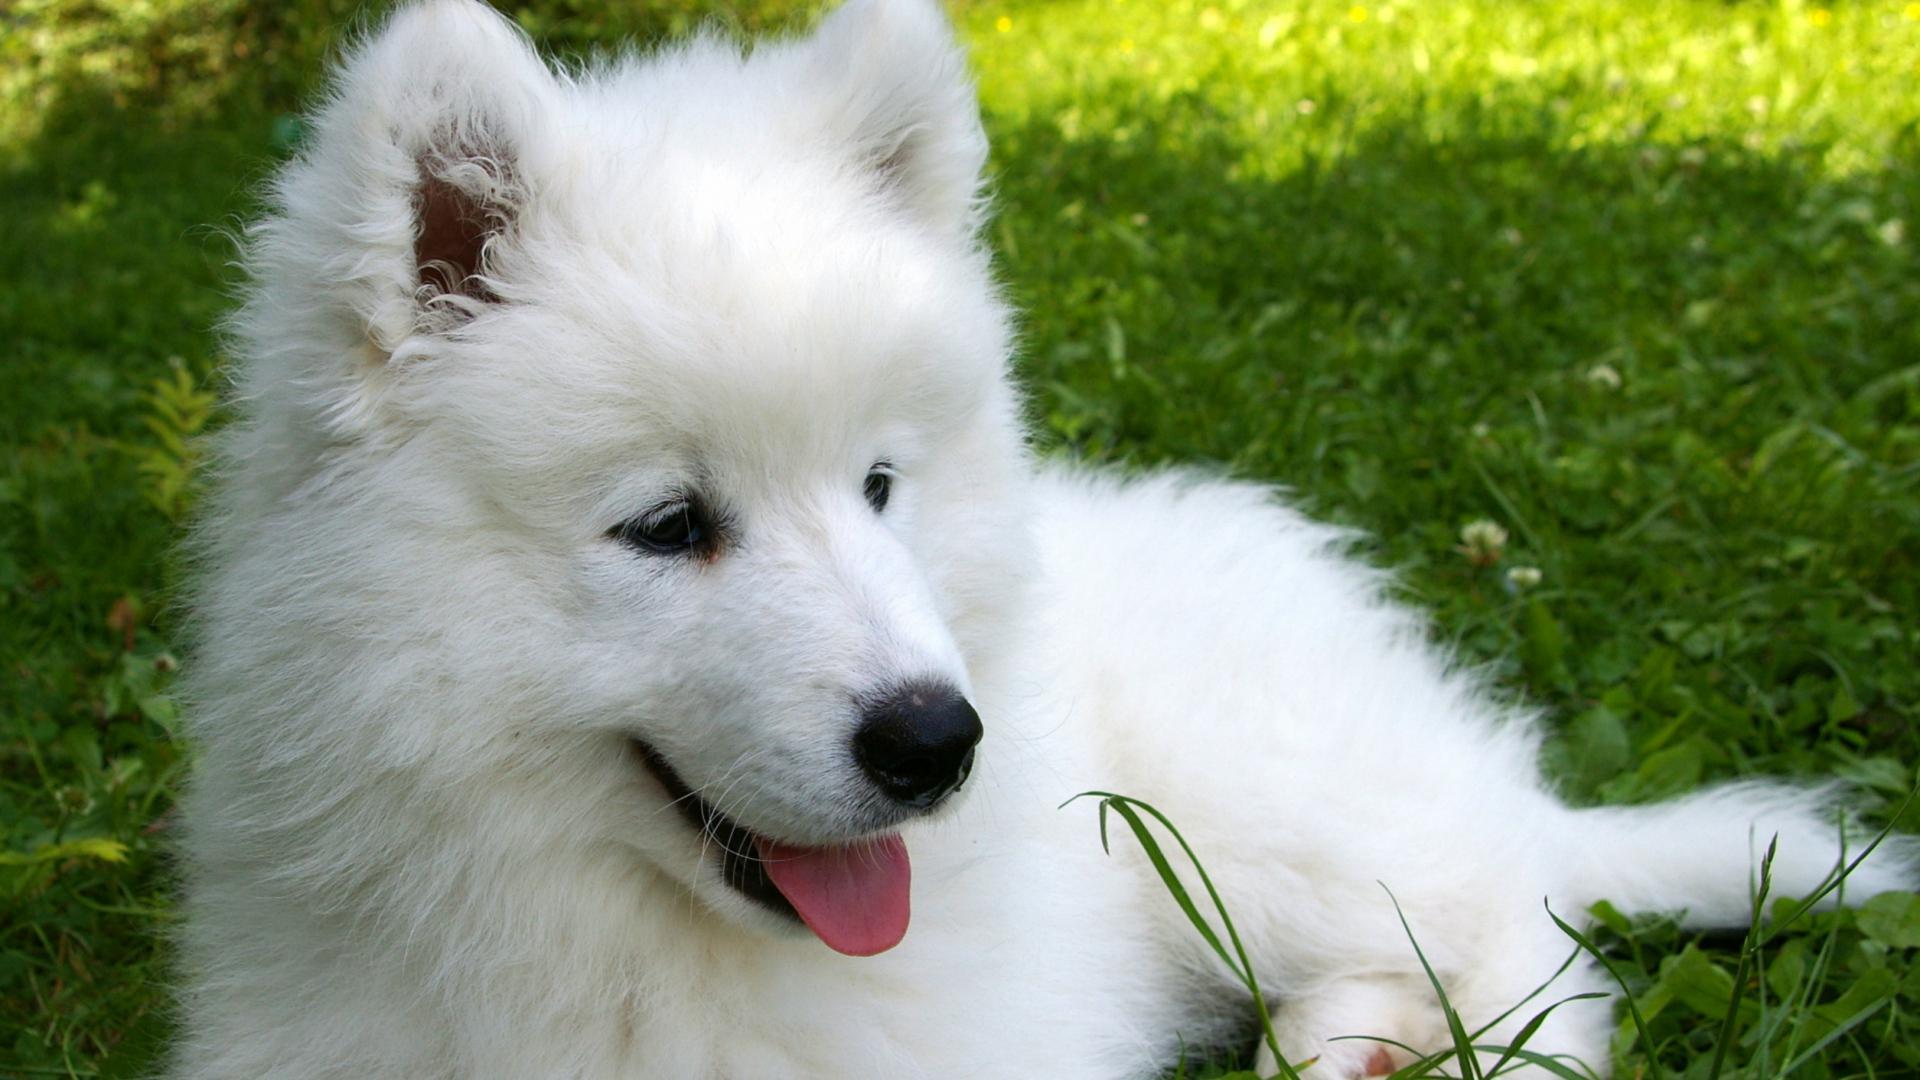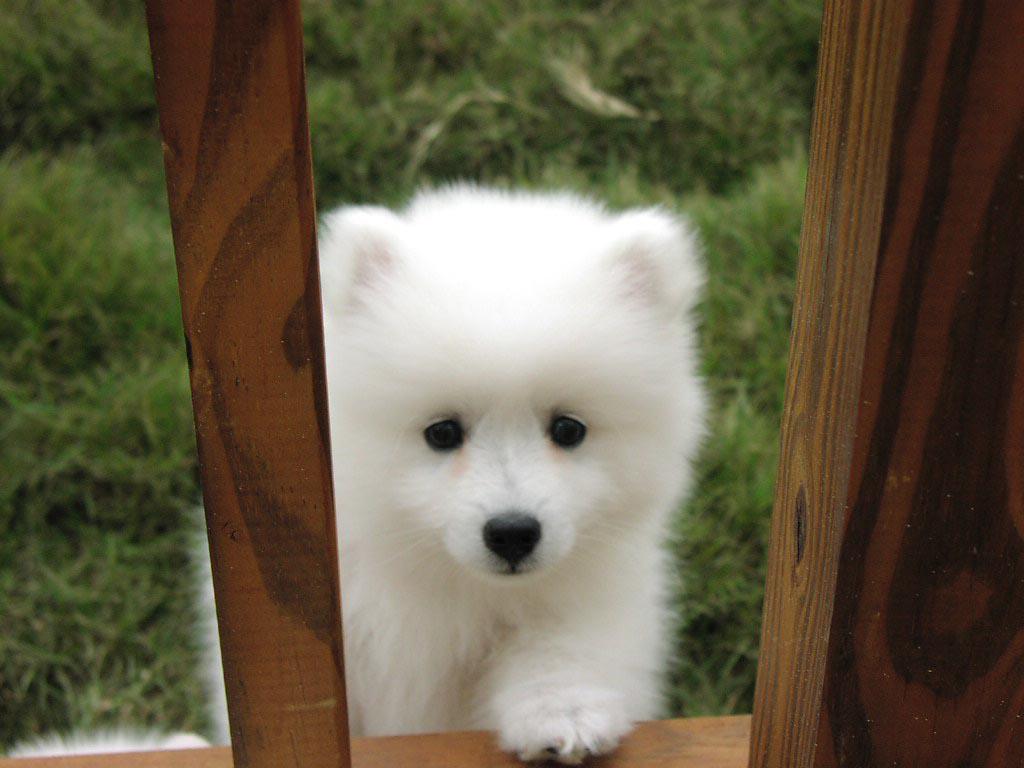The first image is the image on the left, the second image is the image on the right. Considering the images on both sides, is "There are more dogs in the right image than in the left." valid? Answer yes or no. No. 